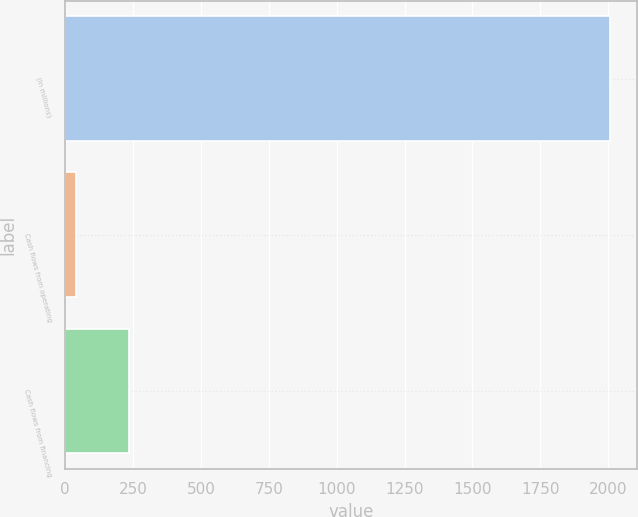Convert chart. <chart><loc_0><loc_0><loc_500><loc_500><bar_chart><fcel>(In millions)<fcel>Cash flows from operating<fcel>Cash flows from financing<nl><fcel>2007<fcel>39<fcel>235.8<nl></chart> 